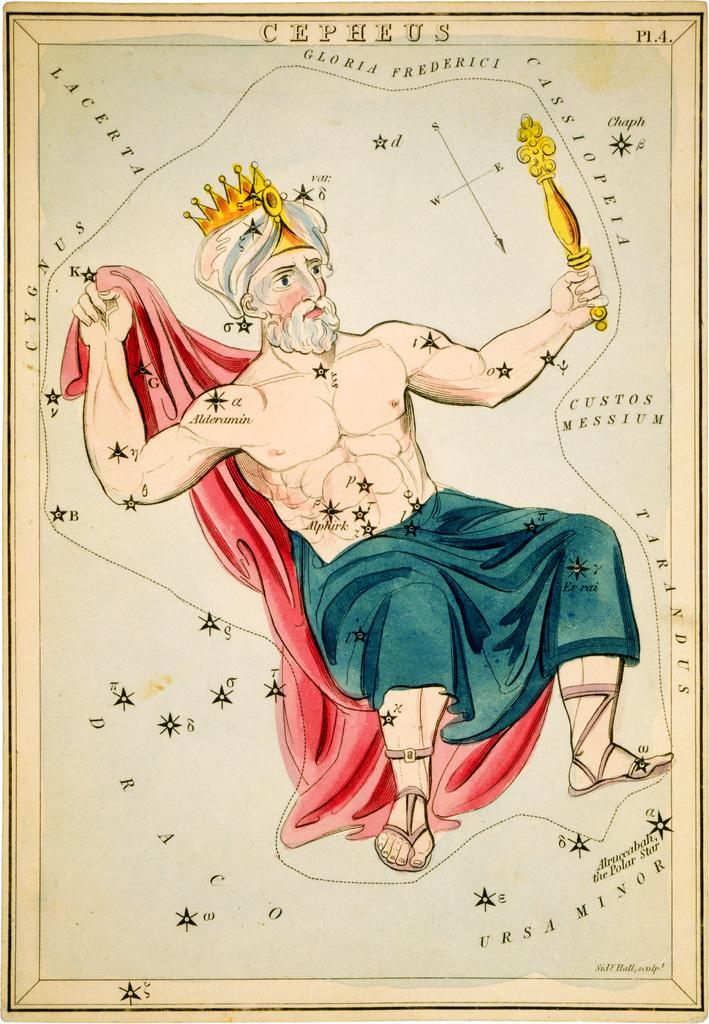Who is present in the image? There is a man in the image. What is the man holding in the image? The man is holding a red cloth. What can be seen on the man's head in the image? The man has a crown on his head. How many men are tricking a cub in the image? There are no men, tricks, or cubs present in the image. 